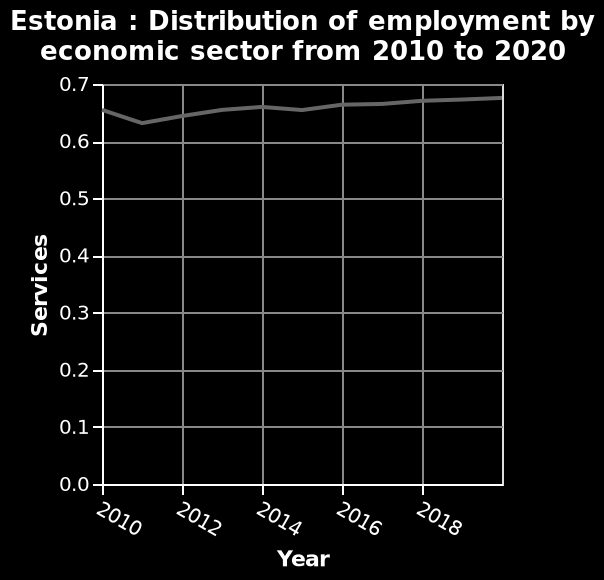<image>
What is the range of the x-axis in the diagram?  The range of the x-axis in the diagram is from 2010 to 2018. 